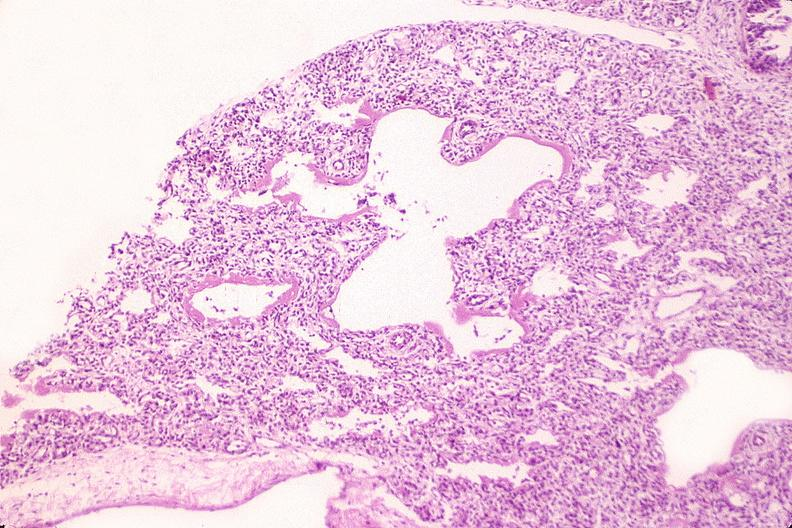does carcinomatosis endometrium primary show lungs, hyaline membrane disease?
Answer the question using a single word or phrase. No 